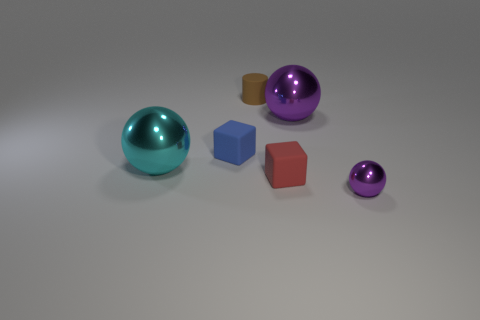Add 3 large cyan shiny balls. How many objects exist? 9 Subtract all cubes. How many objects are left? 4 Subtract 1 cyan balls. How many objects are left? 5 Subtract all metallic objects. Subtract all purple metallic balls. How many objects are left? 1 Add 2 big shiny objects. How many big shiny objects are left? 4 Add 1 red rubber spheres. How many red rubber spheres exist? 1 